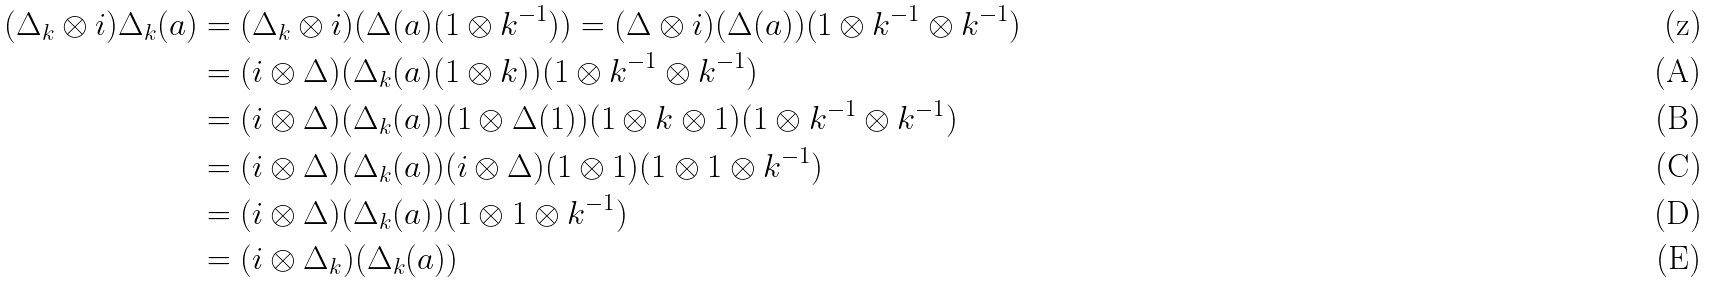Convert formula to latex. <formula><loc_0><loc_0><loc_500><loc_500>( \Delta _ { k } \otimes i ) \Delta _ { k } ( a ) & = ( \Delta _ { k } \otimes i ) ( \Delta ( a ) ( 1 \otimes k ^ { - 1 } ) ) = ( \Delta \otimes i ) ( \Delta ( a ) ) ( 1 \otimes k ^ { - 1 } \otimes k ^ { - 1 } ) \\ & = ( i \otimes \Delta ) ( \Delta _ { k } ( a ) ( 1 \otimes k ) ) ( 1 \otimes k ^ { - 1 } \otimes k ^ { - 1 } ) \\ & = ( i \otimes \Delta ) ( \Delta _ { k } ( a ) ) ( 1 \otimes \Delta ( 1 ) ) ( 1 \otimes k \otimes 1 ) ( 1 \otimes k ^ { - 1 } \otimes k ^ { - 1 } ) \\ & = ( i \otimes \Delta ) ( \Delta _ { k } ( a ) ) ( i \otimes \Delta ) ( 1 \otimes 1 ) ( 1 \otimes 1 \otimes k ^ { - 1 } ) \\ & = ( i \otimes \Delta ) ( \Delta _ { k } ( a ) ) ( 1 \otimes 1 \otimes k ^ { - 1 } ) \\ & = ( i \otimes \Delta _ { k } ) ( \Delta _ { k } ( a ) )</formula> 